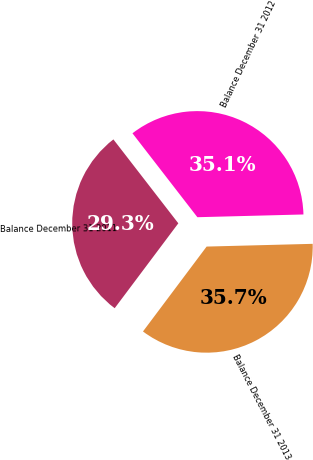Convert chart to OTSL. <chart><loc_0><loc_0><loc_500><loc_500><pie_chart><fcel>Balance December 31 2011<fcel>Balance December 31 2012<fcel>Balance December 31 2013<nl><fcel>29.28%<fcel>35.07%<fcel>35.65%<nl></chart> 